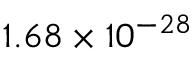Convert formula to latex. <formula><loc_0><loc_0><loc_500><loc_500>1 . 6 8 \times 1 0 ^ { - 2 8 }</formula> 